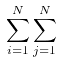<formula> <loc_0><loc_0><loc_500><loc_500>\sum _ { i = 1 } ^ { N } \sum _ { j = 1 } ^ { N }</formula> 